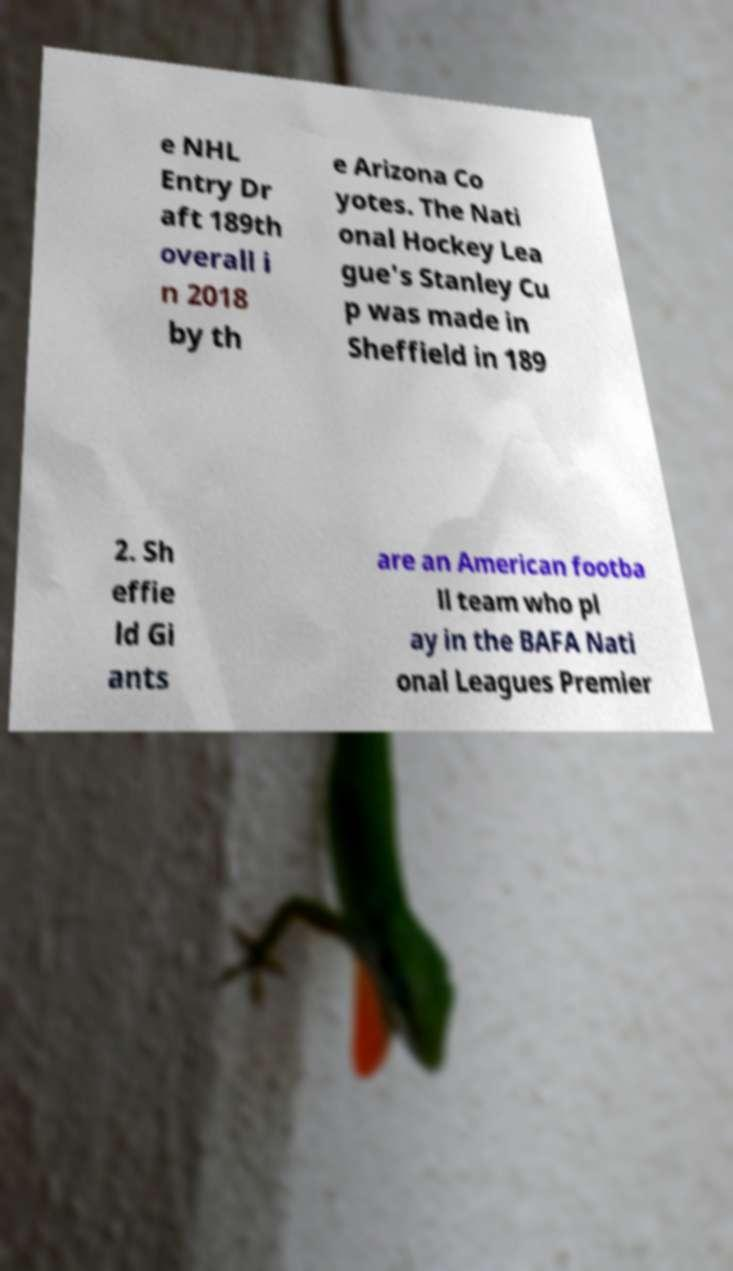What messages or text are displayed in this image? I need them in a readable, typed format. e NHL Entry Dr aft 189th overall i n 2018 by th e Arizona Co yotes. The Nati onal Hockey Lea gue's Stanley Cu p was made in Sheffield in 189 2. Sh effie ld Gi ants are an American footba ll team who pl ay in the BAFA Nati onal Leagues Premier 